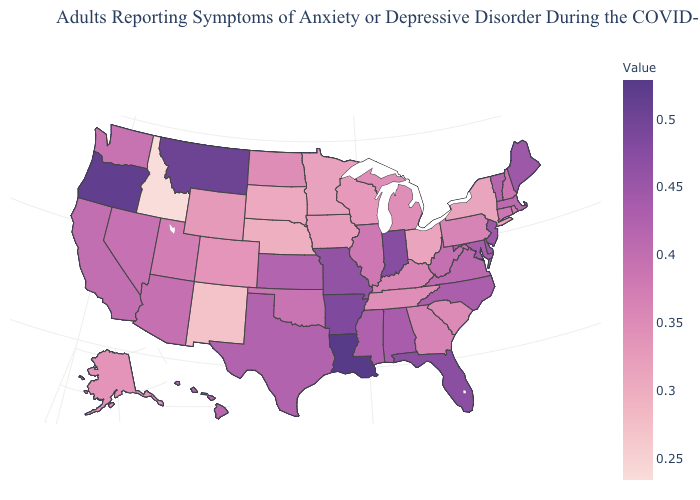Which states hav the highest value in the South?
Short answer required. Louisiana. Which states have the lowest value in the West?
Short answer required. Idaho. Does Nebraska have the lowest value in the MidWest?
Quick response, please. Yes. Does South Carolina have a lower value than Connecticut?
Quick response, please. Yes. Does Missouri have the lowest value in the USA?
Quick response, please. No. Among the states that border South Carolina , which have the lowest value?
Write a very short answer. Georgia. 